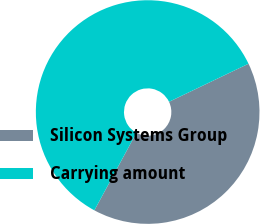Convert chart. <chart><loc_0><loc_0><loc_500><loc_500><pie_chart><fcel>Silicon Systems Group<fcel>Carrying amount<nl><fcel>40.02%<fcel>59.98%<nl></chart> 